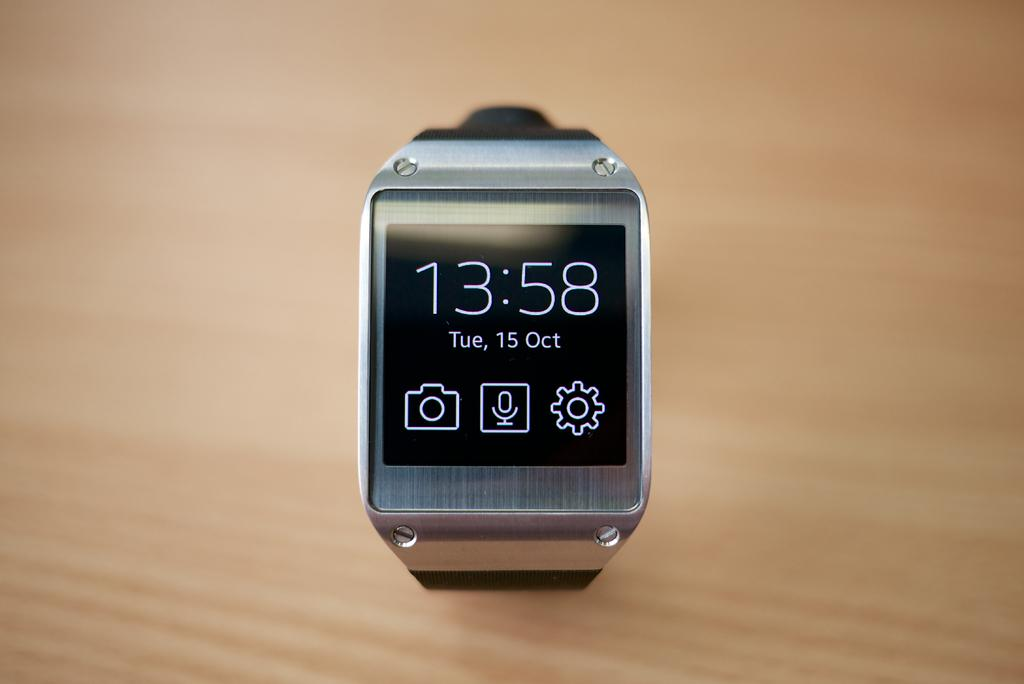<image>
Offer a succinct explanation of the picture presented. An electronic device displays the time of 13:58. 